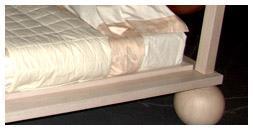How many umbrellas can you see in this photo?
Give a very brief answer. 0. 